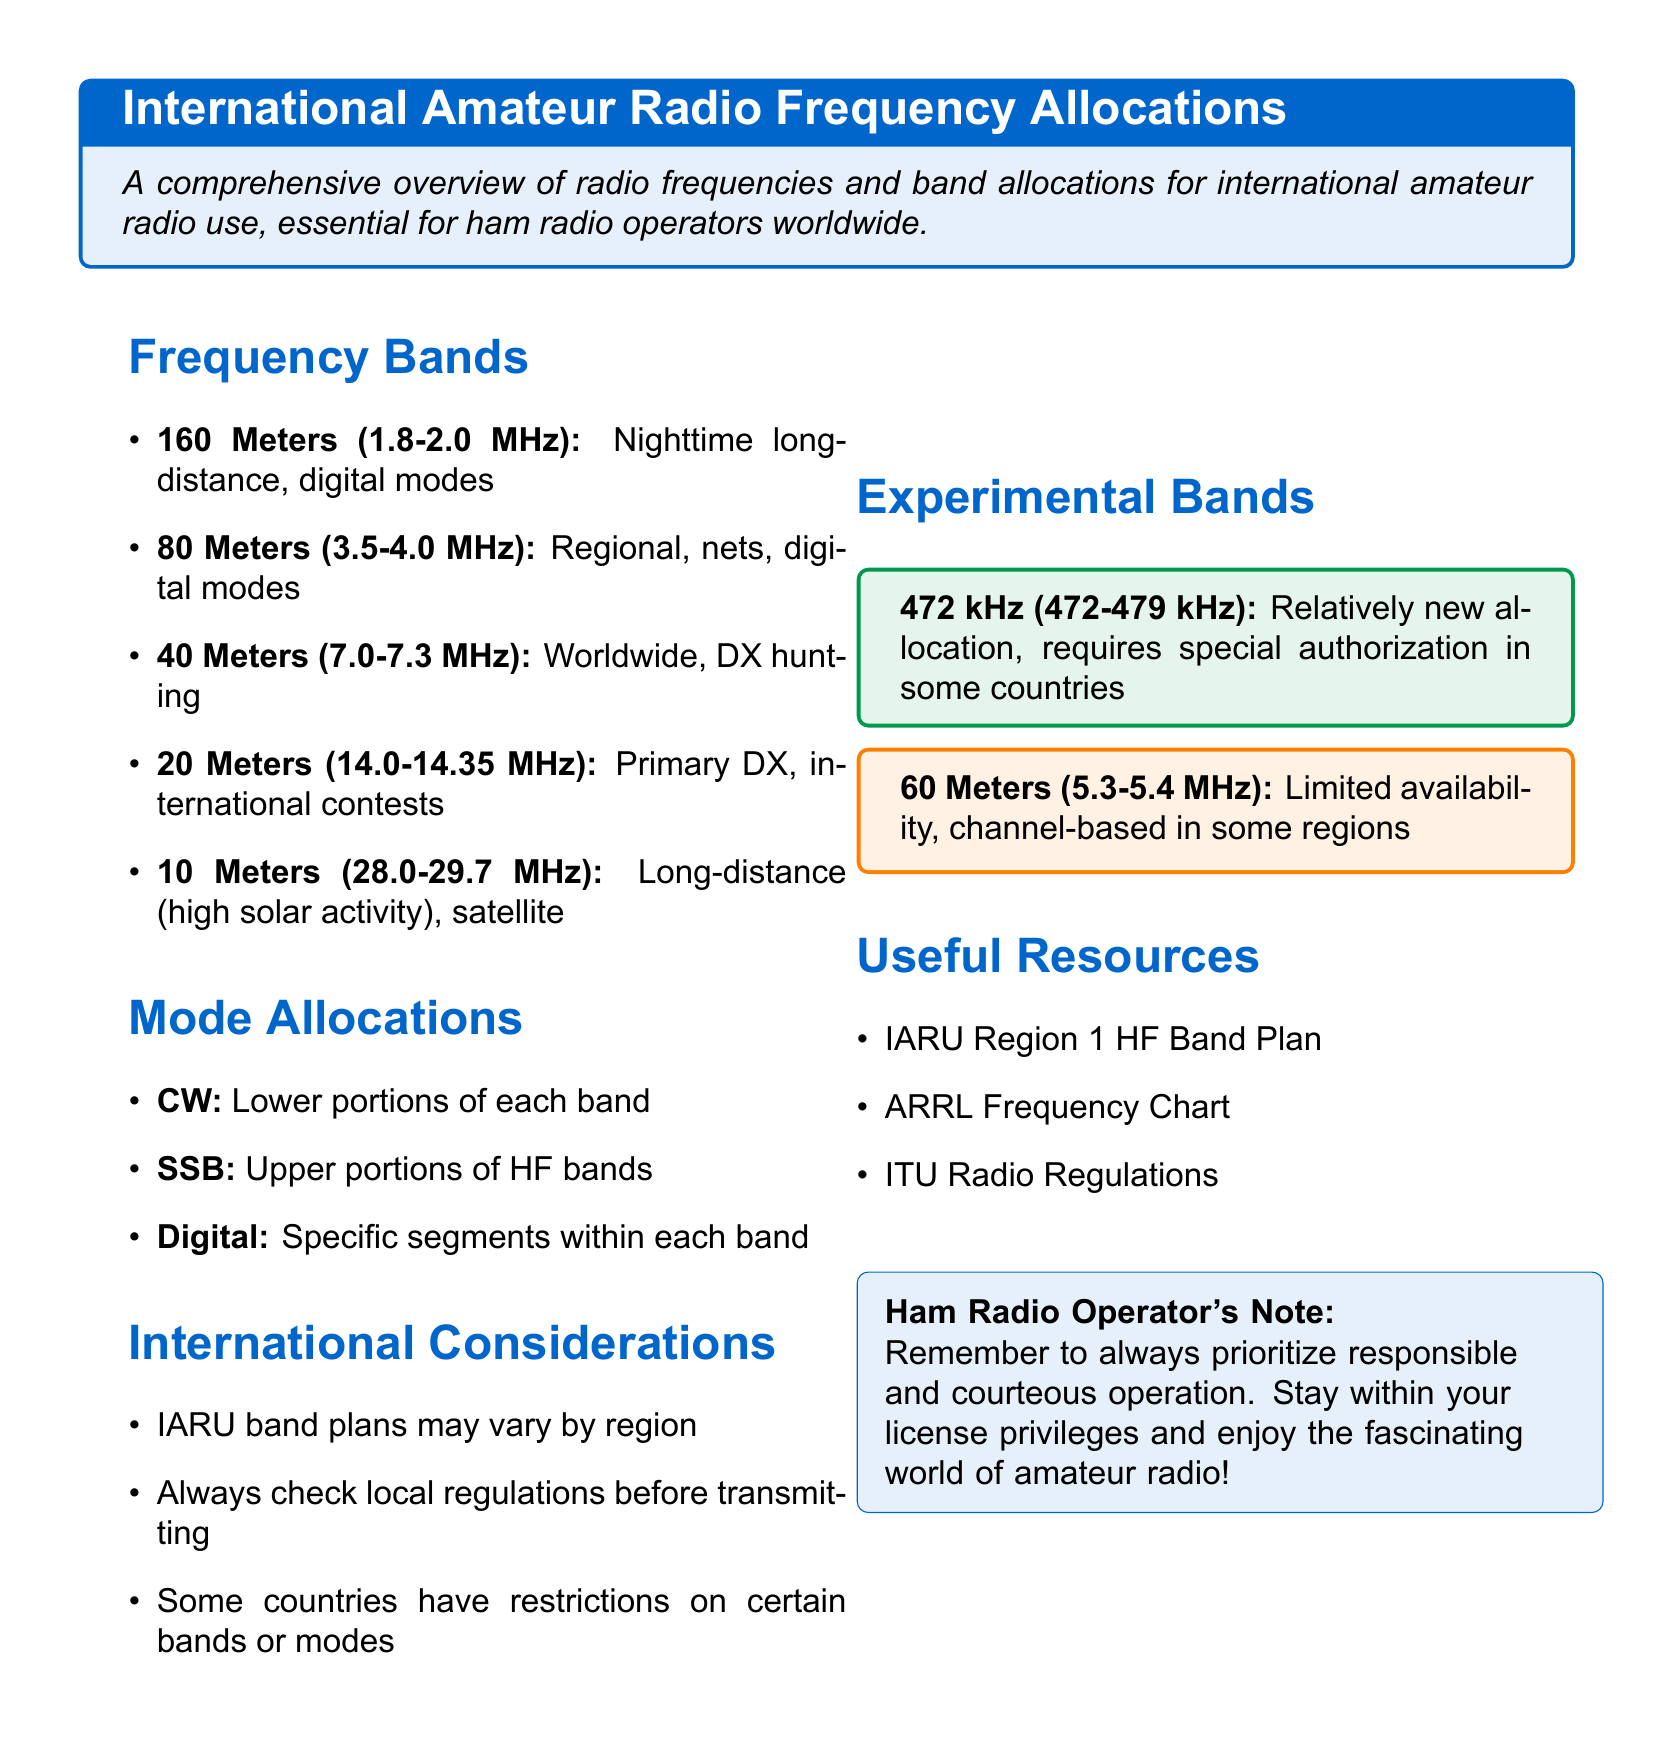What is the range for 160 Meters? The range for 160 Meters is defined within the document as 1.8-2.0 MHz.
Answer: 1.8-2.0 MHz Which frequency band is primarily used for international contests? The document specifies that the 20 Meters band (14.0-14.35 MHz) is primarily used for international contests.
Answer: 20 Meters What allocation requires special authorization in some countries? The document states that the 472 kHz band (472-479 kHz) requires special authorization.
Answer: 472 kHz What does IARU stand for? IARU refers to the International Amateur Radio Union according to the document's context.
Answer: International Amateur Radio Union Which mode is allocated to the upper portions of HF bands? The document indicates that Single Side Band (SSB) is allocated to the upper portions of HF bands.
Answer: SSB Why is it important to check local regulations? The document emphasizes checking local regulations because some countries have restrictions on certain bands or modes.
Answer: Restrictions What is one resource mentioned for amateur radio operators? The document mentions the ARRL Frequency Chart as a resource for amateur radio operators.
Answer: ARRL Frequency Chart 